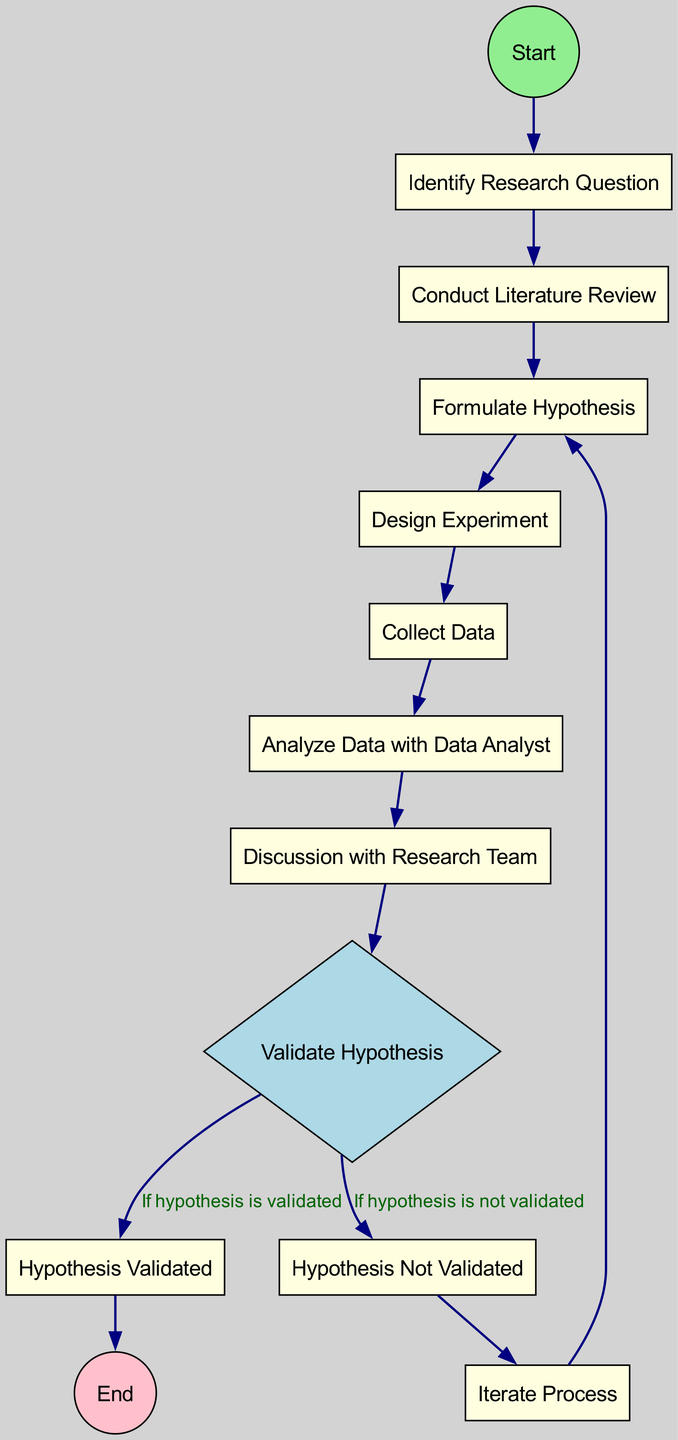What is the first activity in the workflow? The diagram indicates the first activity is labeled "Identify Research Question," which directly follows the "Start" node.
Answer: Identify Research Question How many decision points are in the diagram? The diagram includes one decision point labeled "Validate Hypothesis," which directs the flow based on whether the hypothesis is validated or not.
Answer: 1 What happens if the hypothesis is validated? Following the "Validate Hypothesis" decision point, if the hypothesis is validated, the workflow proceeds to "Hypothesis Validated," leading to the "End" node.
Answer: Hypothesis Validated What is the action taken after data analysis? After "Analyze Data with Data Analyst," the next action is "Discussion with Research Team," representing the continuation of the workflow.
Answer: Discussion with Research Team Which activity follows "Hypothesis Not Validated"? The workflow indicates that after "Hypothesis Not Validated," the next action is "Iterate Process," illustrating the need to revisit earlier steps in the workflow.
Answer: Iterate Process How many activities precede the hypothesis validation? The diagram shows a total of seven activities that occur before reaching "Validate Hypothesis," leading up to the final decision point regarding the hypothesis.
Answer: 7 If the hypothesis is not validated, what is the next step? If the hypothesis is not validated, the workflow directs to the "Iterate Process," which indicates that the process will loop back to "Formulate Hypothesis."
Answer: Iterate Process What is the last node in the diagram? The last node in the workflow, as indicated in the diagram, is "End," which signifies the conclusion of the hypothesis formulation and validation process.
Answer: End 